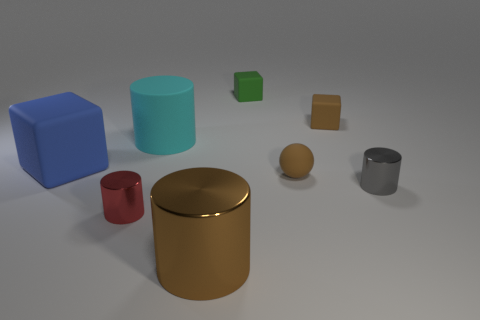Add 1 cyan cylinders. How many objects exist? 9 Subtract all blocks. How many objects are left? 5 Subtract all blue rubber objects. Subtract all big rubber spheres. How many objects are left? 7 Add 5 red metal cylinders. How many red metal cylinders are left? 6 Add 2 small gray cylinders. How many small gray cylinders exist? 3 Subtract 0 purple cubes. How many objects are left? 8 